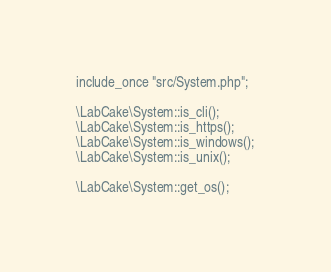Convert code to text. <code><loc_0><loc_0><loc_500><loc_500><_PHP_>include_once "src/System.php";

\LabCake\System::is_cli();
\LabCake\System::is_https();
\LabCake\System::is_windows();
\LabCake\System::is_unix();

\LabCake\System::get_os();</code> 